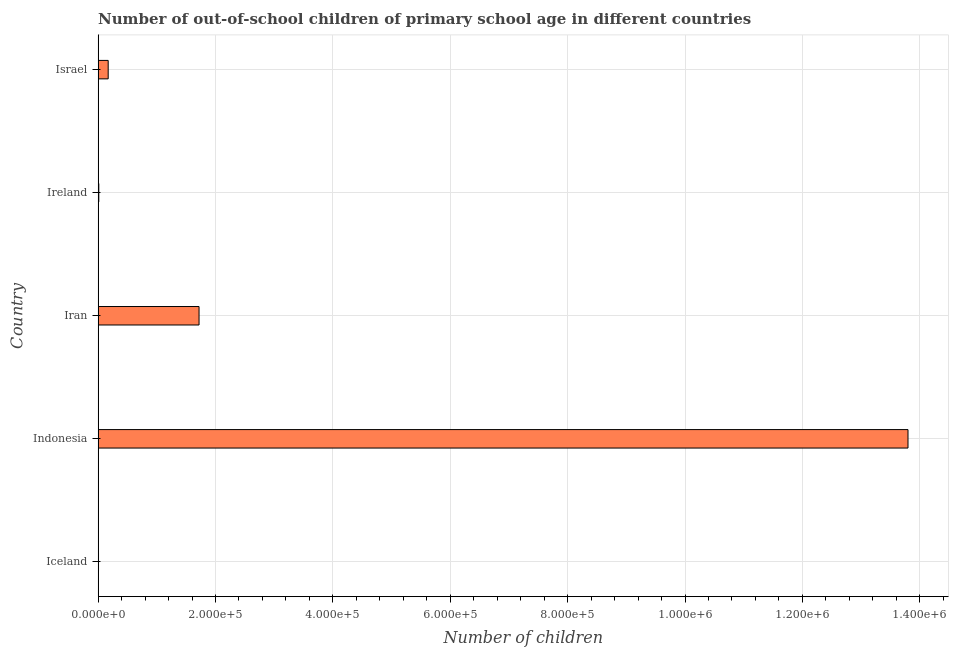Does the graph contain any zero values?
Your answer should be compact. No. Does the graph contain grids?
Your answer should be very brief. Yes. What is the title of the graph?
Your answer should be very brief. Number of out-of-school children of primary school age in different countries. What is the label or title of the X-axis?
Make the answer very short. Number of children. What is the label or title of the Y-axis?
Offer a very short reply. Country. What is the number of out-of-school children in Iran?
Offer a very short reply. 1.72e+05. Across all countries, what is the maximum number of out-of-school children?
Ensure brevity in your answer.  1.38e+06. Across all countries, what is the minimum number of out-of-school children?
Offer a very short reply. 670. In which country was the number of out-of-school children maximum?
Keep it short and to the point. Indonesia. In which country was the number of out-of-school children minimum?
Your answer should be very brief. Iceland. What is the sum of the number of out-of-school children?
Offer a very short reply. 1.57e+06. What is the difference between the number of out-of-school children in Indonesia and Ireland?
Offer a very short reply. 1.38e+06. What is the average number of out-of-school children per country?
Make the answer very short. 3.14e+05. What is the median number of out-of-school children?
Keep it short and to the point. 1.72e+04. In how many countries, is the number of out-of-school children greater than 880000 ?
Your answer should be very brief. 1. What is the ratio of the number of out-of-school children in Iceland to that in Iran?
Ensure brevity in your answer.  0. Is the number of out-of-school children in Indonesia less than that in Israel?
Provide a short and direct response. No. Is the difference between the number of out-of-school children in Indonesia and Ireland greater than the difference between any two countries?
Your answer should be compact. No. What is the difference between the highest and the second highest number of out-of-school children?
Keep it short and to the point. 1.21e+06. What is the difference between the highest and the lowest number of out-of-school children?
Offer a terse response. 1.38e+06. How many bars are there?
Offer a terse response. 5. Are all the bars in the graph horizontal?
Keep it short and to the point. Yes. How many countries are there in the graph?
Your response must be concise. 5. What is the difference between two consecutive major ticks on the X-axis?
Your answer should be compact. 2.00e+05. Are the values on the major ticks of X-axis written in scientific E-notation?
Ensure brevity in your answer.  Yes. What is the Number of children in Iceland?
Offer a terse response. 670. What is the Number of children in Indonesia?
Keep it short and to the point. 1.38e+06. What is the Number of children of Iran?
Offer a very short reply. 1.72e+05. What is the Number of children of Ireland?
Your answer should be compact. 1161. What is the Number of children in Israel?
Give a very brief answer. 1.72e+04. What is the difference between the Number of children in Iceland and Indonesia?
Offer a very short reply. -1.38e+06. What is the difference between the Number of children in Iceland and Iran?
Keep it short and to the point. -1.71e+05. What is the difference between the Number of children in Iceland and Ireland?
Your answer should be compact. -491. What is the difference between the Number of children in Iceland and Israel?
Give a very brief answer. -1.65e+04. What is the difference between the Number of children in Indonesia and Iran?
Ensure brevity in your answer.  1.21e+06. What is the difference between the Number of children in Indonesia and Ireland?
Provide a short and direct response. 1.38e+06. What is the difference between the Number of children in Indonesia and Israel?
Your answer should be very brief. 1.36e+06. What is the difference between the Number of children in Iran and Ireland?
Make the answer very short. 1.71e+05. What is the difference between the Number of children in Iran and Israel?
Ensure brevity in your answer.  1.55e+05. What is the difference between the Number of children in Ireland and Israel?
Provide a succinct answer. -1.60e+04. What is the ratio of the Number of children in Iceland to that in Indonesia?
Ensure brevity in your answer.  0. What is the ratio of the Number of children in Iceland to that in Iran?
Make the answer very short. 0. What is the ratio of the Number of children in Iceland to that in Ireland?
Keep it short and to the point. 0.58. What is the ratio of the Number of children in Iceland to that in Israel?
Your answer should be compact. 0.04. What is the ratio of the Number of children in Indonesia to that in Iran?
Your answer should be compact. 8.03. What is the ratio of the Number of children in Indonesia to that in Ireland?
Give a very brief answer. 1188.62. What is the ratio of the Number of children in Indonesia to that in Israel?
Make the answer very short. 80.43. What is the ratio of the Number of children in Iran to that in Ireland?
Make the answer very short. 148.12. What is the ratio of the Number of children in Iran to that in Israel?
Offer a terse response. 10.02. What is the ratio of the Number of children in Ireland to that in Israel?
Offer a very short reply. 0.07. 